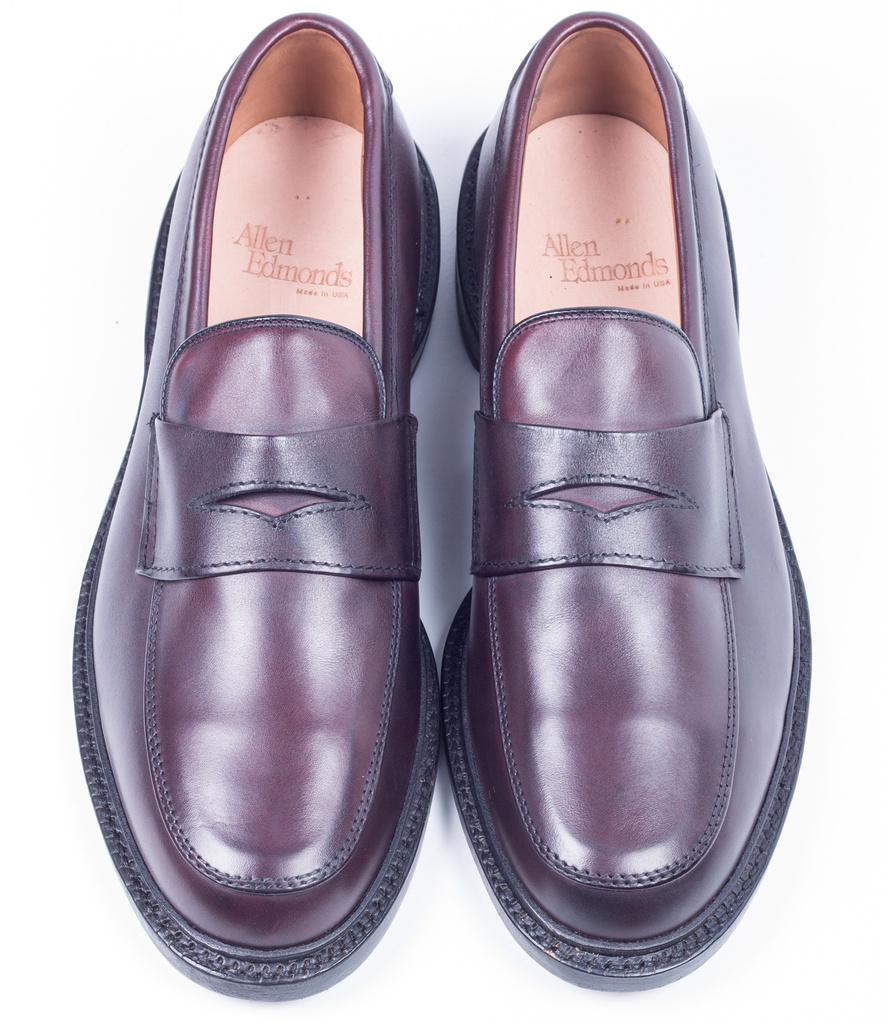What type of footwear is visible in the image? There is a pair of shoes in the image. What colors are the shoes? The shoes are black and brown in color. Is there any text or branding associated with the shoes? Yes, there is a name, Allen Edmond, under the shoes. How many pigs are visible in the image? There are no pigs present in the image; it features a pair of shoes. What type of tail is attached to the shoes in the image? There is no tail attached to the shoes in the image. 